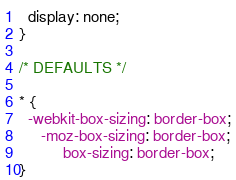<code> <loc_0><loc_0><loc_500><loc_500><_CSS_>  display: none;
}

/* DEFAULTS */

* {
  -webkit-box-sizing: border-box;
     -moz-box-sizing: border-box;
          box-sizing: border-box;
}</code> 